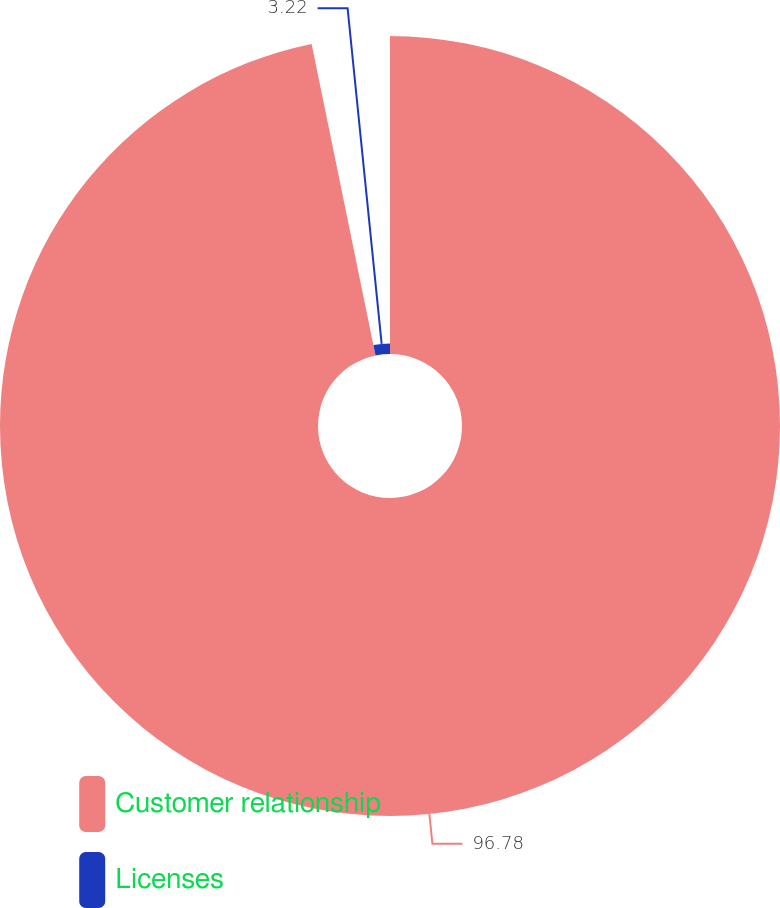Convert chart. <chart><loc_0><loc_0><loc_500><loc_500><pie_chart><fcel>Customer relationship<fcel>Licenses<nl><fcel>96.78%<fcel>3.22%<nl></chart> 